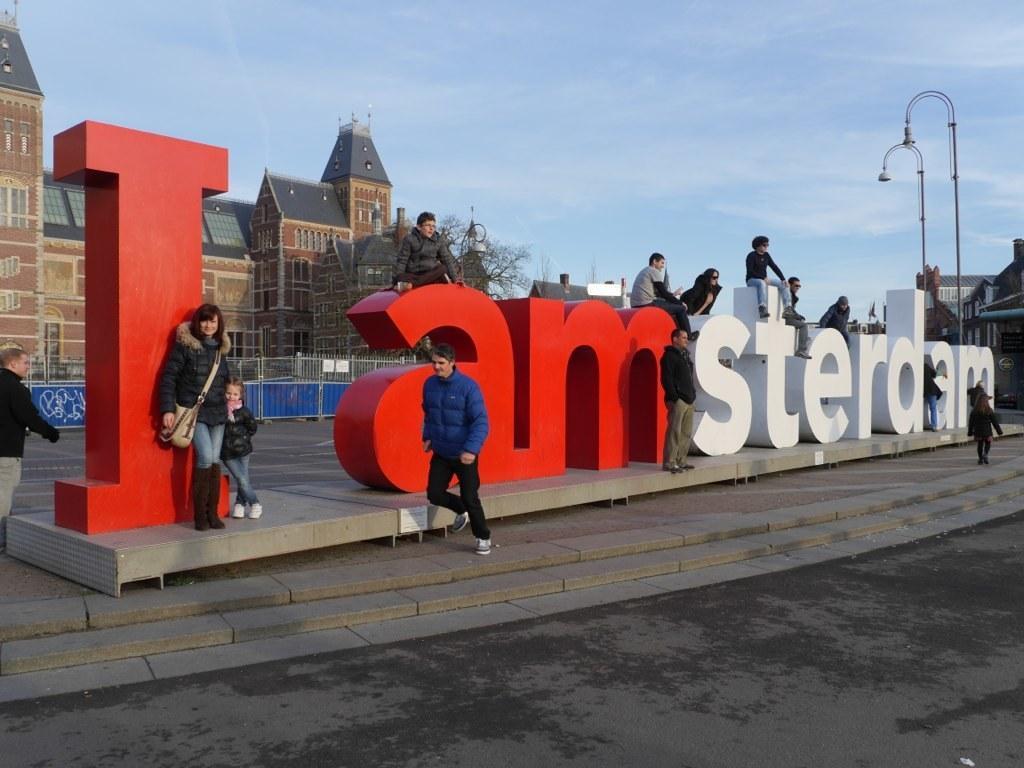Can you describe this image briefly? There is a road. Near to that there are steps. And there is a platform. On that something is written. Some people are standing, sitting and walking near to that. Also there are poles. In the background there are trees, buildings, sky and railings. 